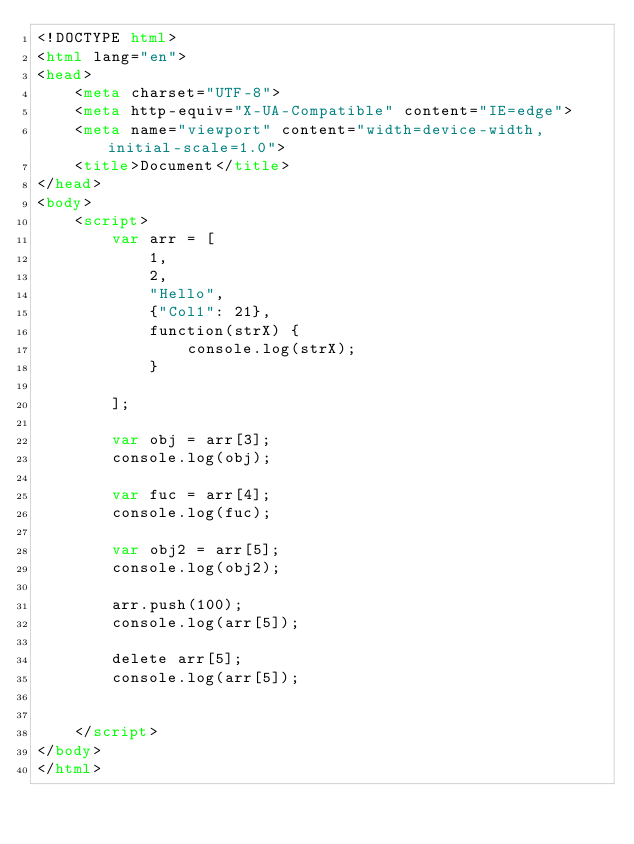<code> <loc_0><loc_0><loc_500><loc_500><_HTML_><!DOCTYPE html>
<html lang="en">
<head>
    <meta charset="UTF-8">
    <meta http-equiv="X-UA-Compatible" content="IE=edge">
    <meta name="viewport" content="width=device-width, initial-scale=1.0">
    <title>Document</title>
</head>
<body>
    <script>
        var arr = [
            1,
            2,
            "Hello",
            {"Col1": 21},
            function(strX) {
                console.log(strX);
            }

        ];

        var obj = arr[3];
        console.log(obj);

        var fuc = arr[4];
        console.log(fuc);

        var obj2 = arr[5];
        console.log(obj2);

        arr.push(100);
        console.log(arr[5]);

        delete arr[5];
        console.log(arr[5]);

        
    </script>
</body>
</html></code> 